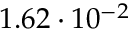<formula> <loc_0><loc_0><loc_500><loc_500>1 . 6 2 \cdot 1 0 ^ { - 2 }</formula> 